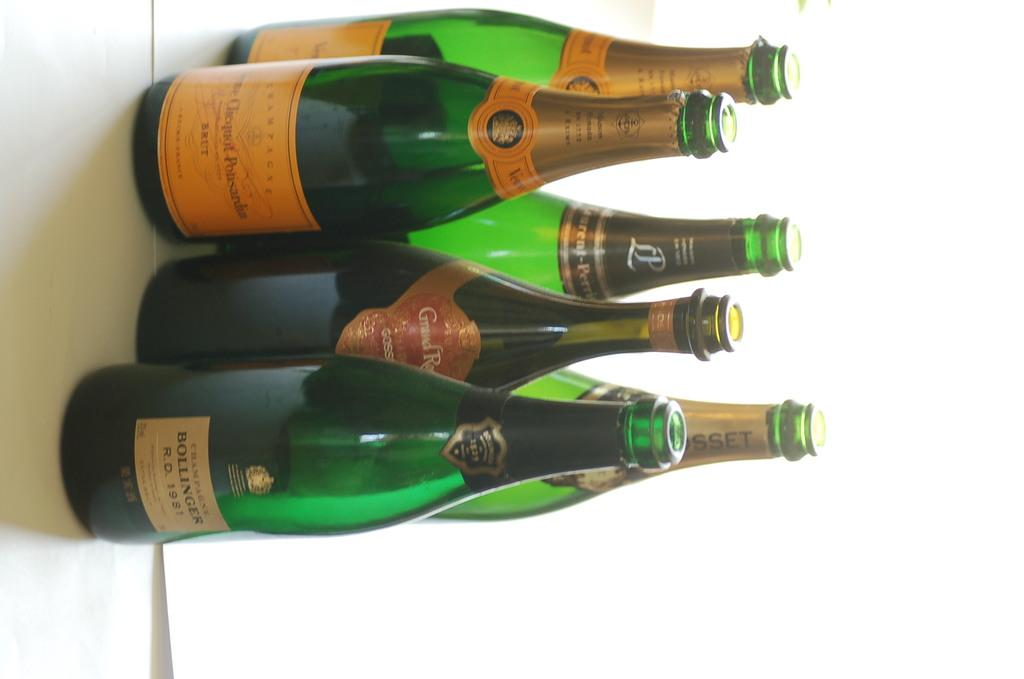How many bottles are visible in the image? There are six bottles in the image. Where are the bottles located? The bottles are placed on a table. What is the state of the bottles in the image? The bottles are opened. What decision did the dolls make in the image? There are no dolls present in the image, so no decision can be attributed to them. 